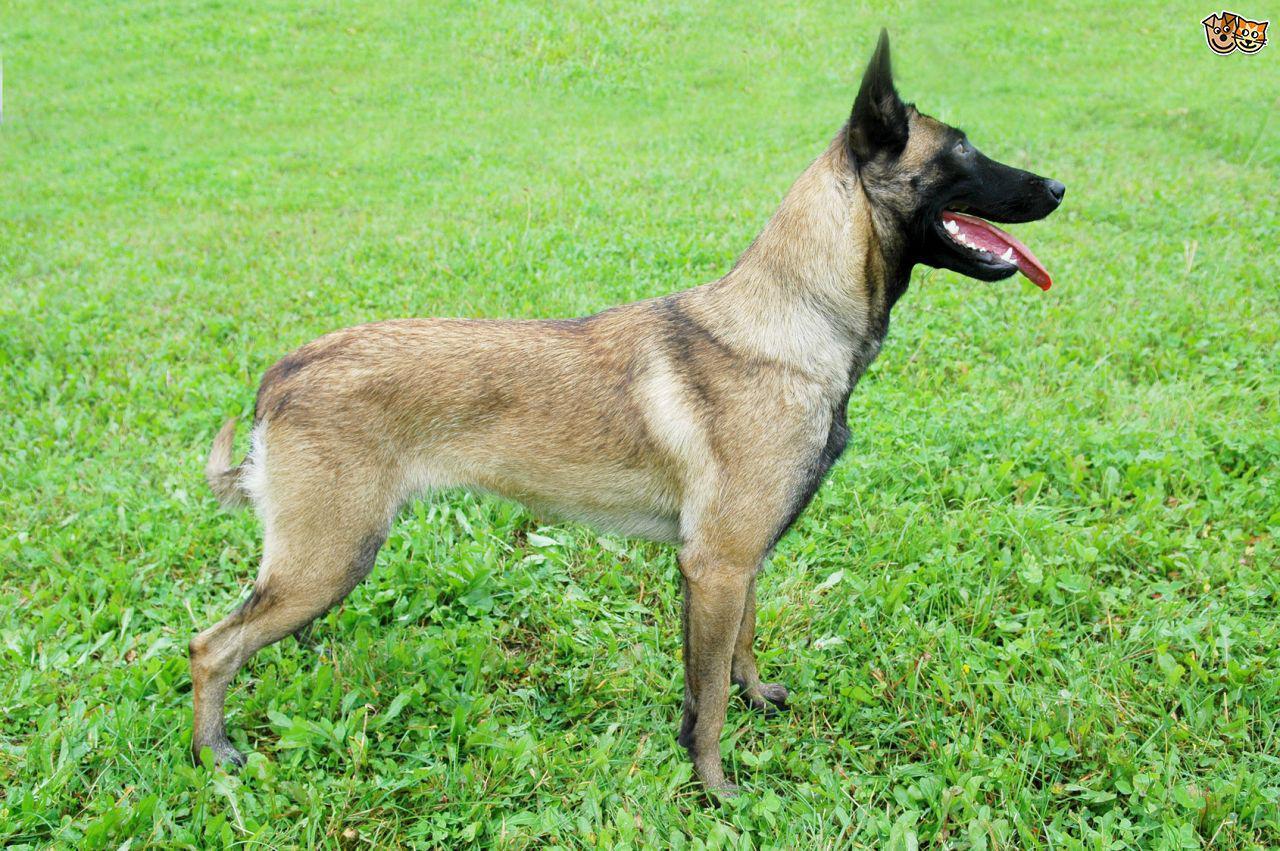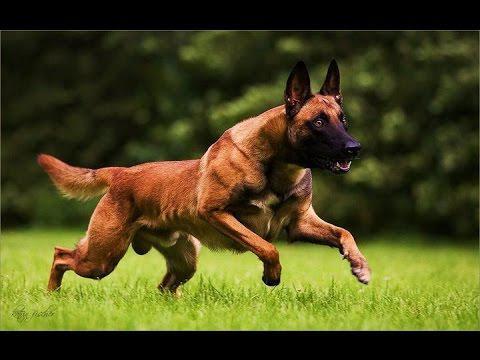The first image is the image on the left, the second image is the image on the right. Considering the images on both sides, is "A dog is pictured against a plain white backgroun." valid? Answer yes or no. No. 